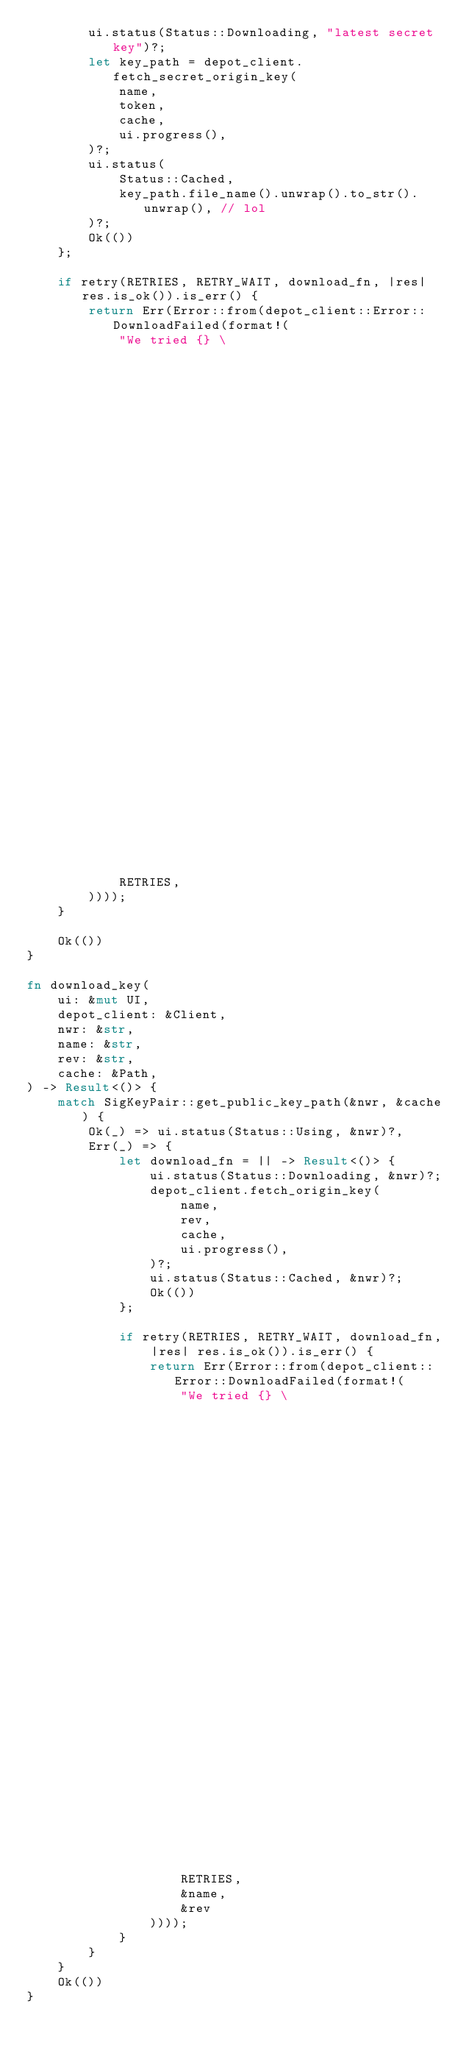<code> <loc_0><loc_0><loc_500><loc_500><_Rust_>        ui.status(Status::Downloading, "latest secret key")?;
        let key_path = depot_client.fetch_secret_origin_key(
            name,
            token,
            cache,
            ui.progress(),
        )?;
        ui.status(
            Status::Cached,
            key_path.file_name().unwrap().to_str().unwrap(), // lol
        )?;
        Ok(())
    };

    if retry(RETRIES, RETRY_WAIT, download_fn, |res| res.is_ok()).is_err() {
        return Err(Error::from(depot_client::Error::DownloadFailed(format!(
            "We tried {} \
                                                                            times but \
                                                                            could not \
                                                                            download the latest \
                                                                            secret origin key. \
                                                                            Giving up.",
            RETRIES,
        ))));
    }

    Ok(())
}

fn download_key(
    ui: &mut UI,
    depot_client: &Client,
    nwr: &str,
    name: &str,
    rev: &str,
    cache: &Path,
) -> Result<()> {
    match SigKeyPair::get_public_key_path(&nwr, &cache) {
        Ok(_) => ui.status(Status::Using, &nwr)?,
        Err(_) => {
            let download_fn = || -> Result<()> {
                ui.status(Status::Downloading, &nwr)?;
                depot_client.fetch_origin_key(
                    name,
                    rev,
                    cache,
                    ui.progress(),
                )?;
                ui.status(Status::Cached, &nwr)?;
                Ok(())
            };

            if retry(RETRIES, RETRY_WAIT, download_fn, |res| res.is_ok()).is_err() {
                return Err(Error::from(depot_client::Error::DownloadFailed(format!(
                    "We tried {} \
                                                                                    times but \
                                                                                    could not \
                                                                                    download {}/{} \
                                                                                    origin key. \
                                                                                    Giving up.",
                    RETRIES,
                    &name,
                    &rev
                ))));
            }
        }
    }
    Ok(())
}
</code> 